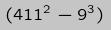Convert formula to latex. <formula><loc_0><loc_0><loc_500><loc_500>( 4 1 1 ^ { 2 } - 9 ^ { 3 } )</formula> 